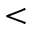Convert formula to latex. <formula><loc_0><loc_0><loc_500><loc_500><</formula> 